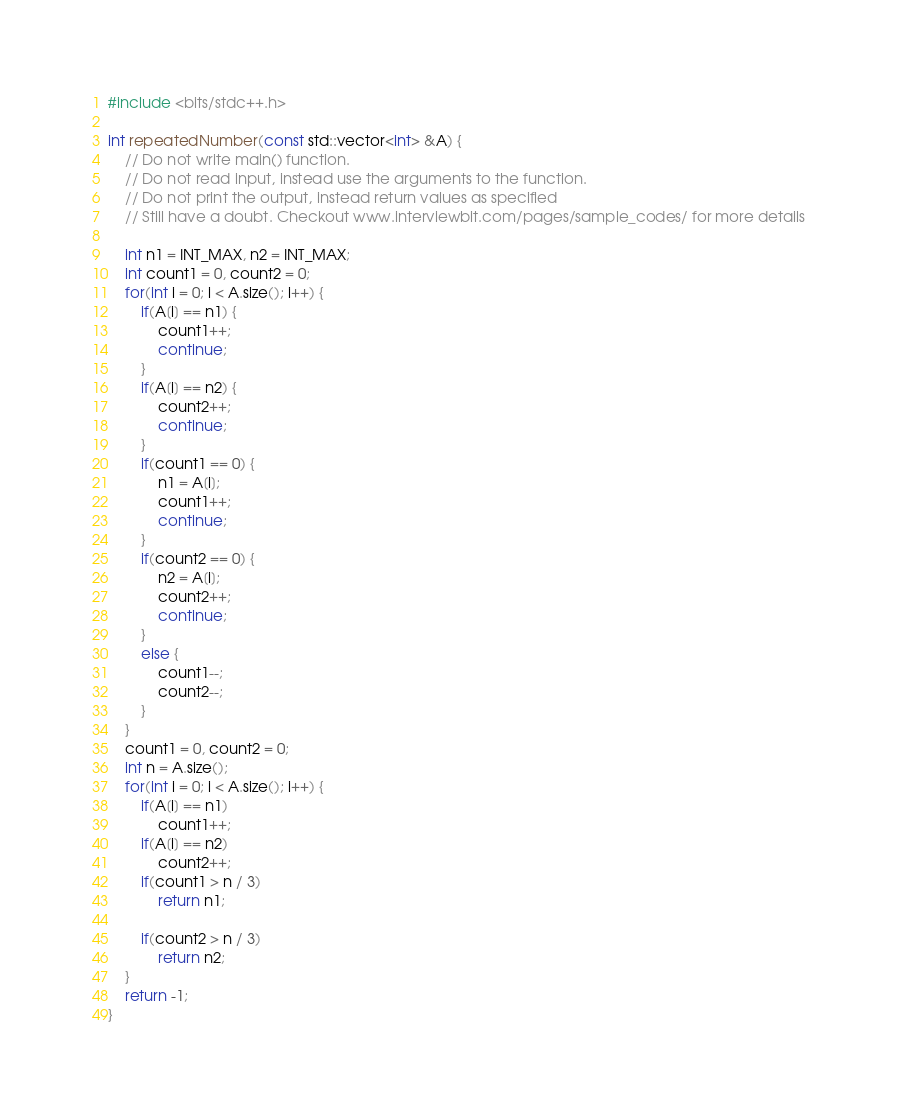<code> <loc_0><loc_0><loc_500><loc_500><_C++_>#include <bits/stdc++.h>

int repeatedNumber(const std::vector<int> &A) {
    // Do not write main() function.
    // Do not read input, instead use the arguments to the function.
    // Do not print the output, instead return values as specified
    // Still have a doubt. Checkout www.interviewbit.com/pages/sample_codes/ for more details

    int n1 = INT_MAX, n2 = INT_MAX;
    int count1 = 0, count2 = 0;
    for(int i = 0; i < A.size(); i++) {
        if(A[i] == n1) {
            count1++;
            continue;
        }
        if(A[i] == n2) {
            count2++;
            continue;
        }
        if(count1 == 0) {
            n1 = A[i];
            count1++;
            continue;
        }
        if(count2 == 0) {
            n2 = A[i];
            count2++;
            continue;
        }
        else {
            count1--;
            count2--;
        }
    }
    count1 = 0, count2 = 0;
    int n = A.size();
    for(int i = 0; i < A.size(); i++) {
        if(A[i] == n1)
            count1++;
        if(A[i] == n2)
            count2++;
        if(count1 > n / 3)
            return n1;
        
        if(count2 > n / 3)
            return n2;
    }
    return -1;
}
</code> 